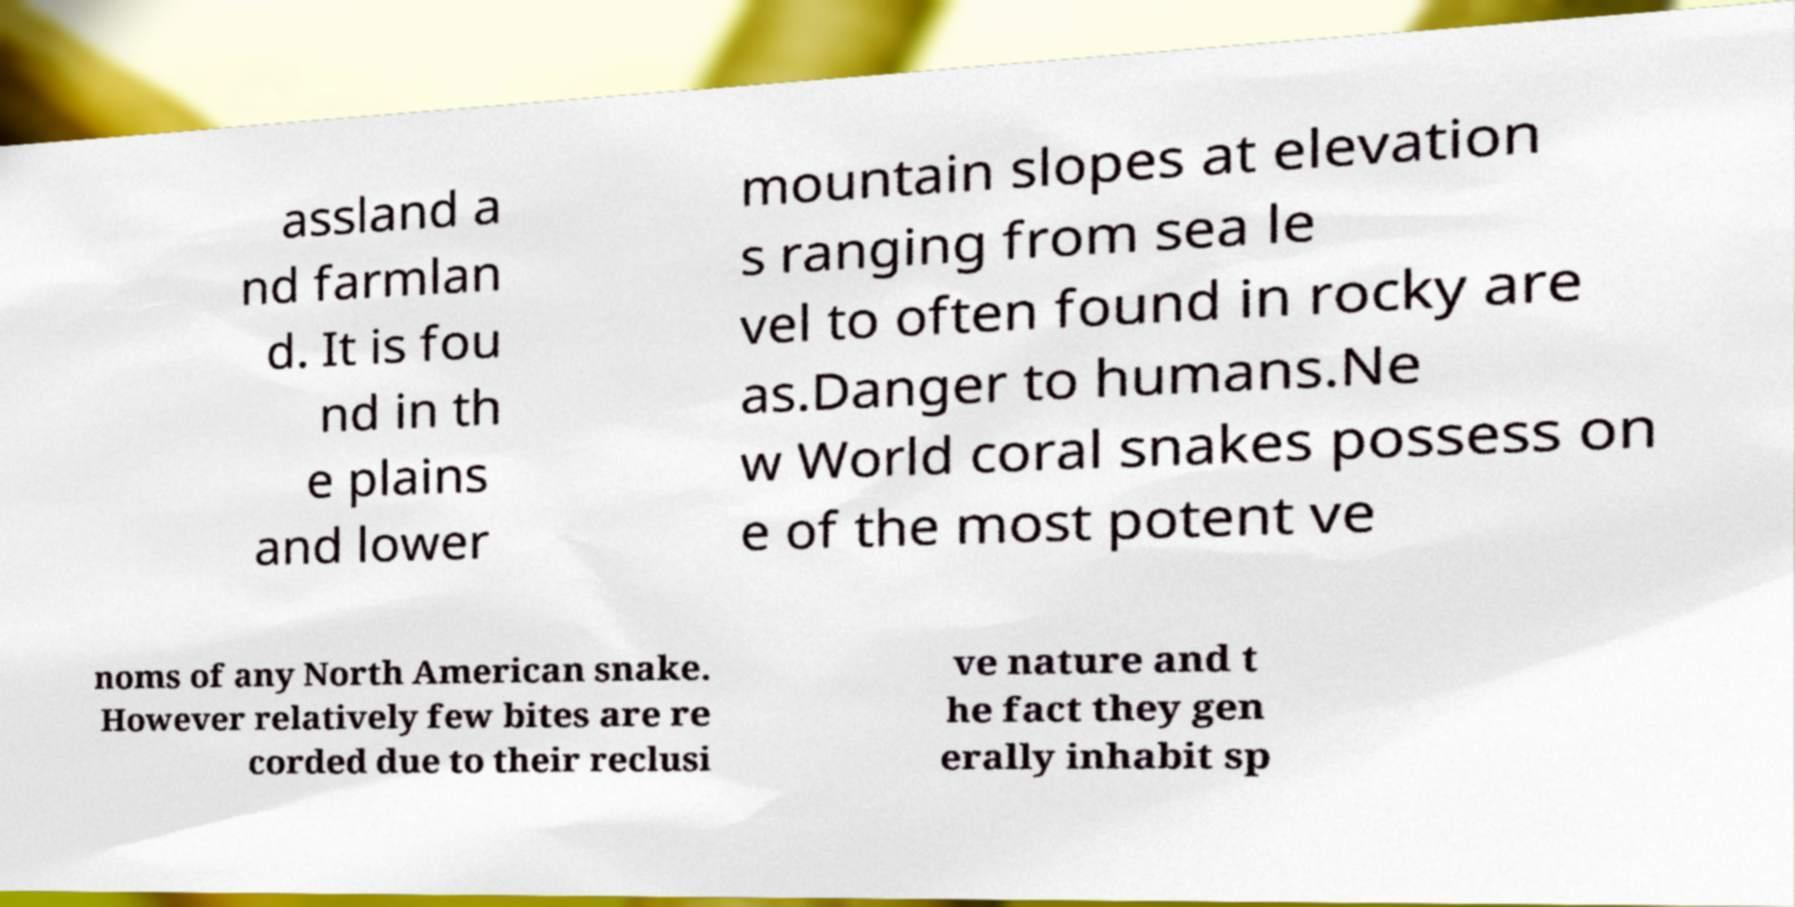Please identify and transcribe the text found in this image. assland a nd farmlan d. It is fou nd in th e plains and lower mountain slopes at elevation s ranging from sea le vel to often found in rocky are as.Danger to humans.Ne w World coral snakes possess on e of the most potent ve noms of any North American snake. However relatively few bites are re corded due to their reclusi ve nature and t he fact they gen erally inhabit sp 